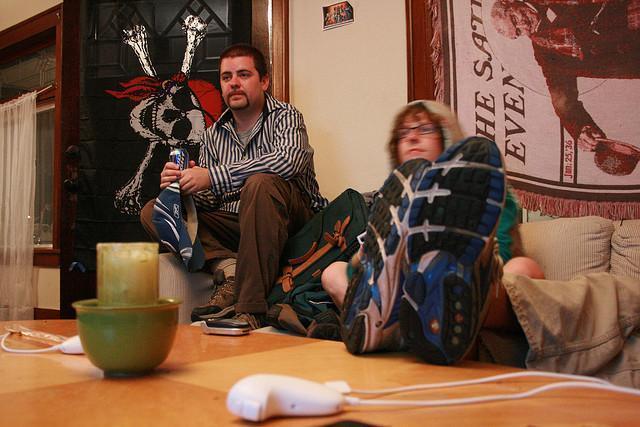What is the man on the left drinking?
Choose the right answer from the provided options to respond to the question.
Options: Juice, wine, water, beer. Beer. 